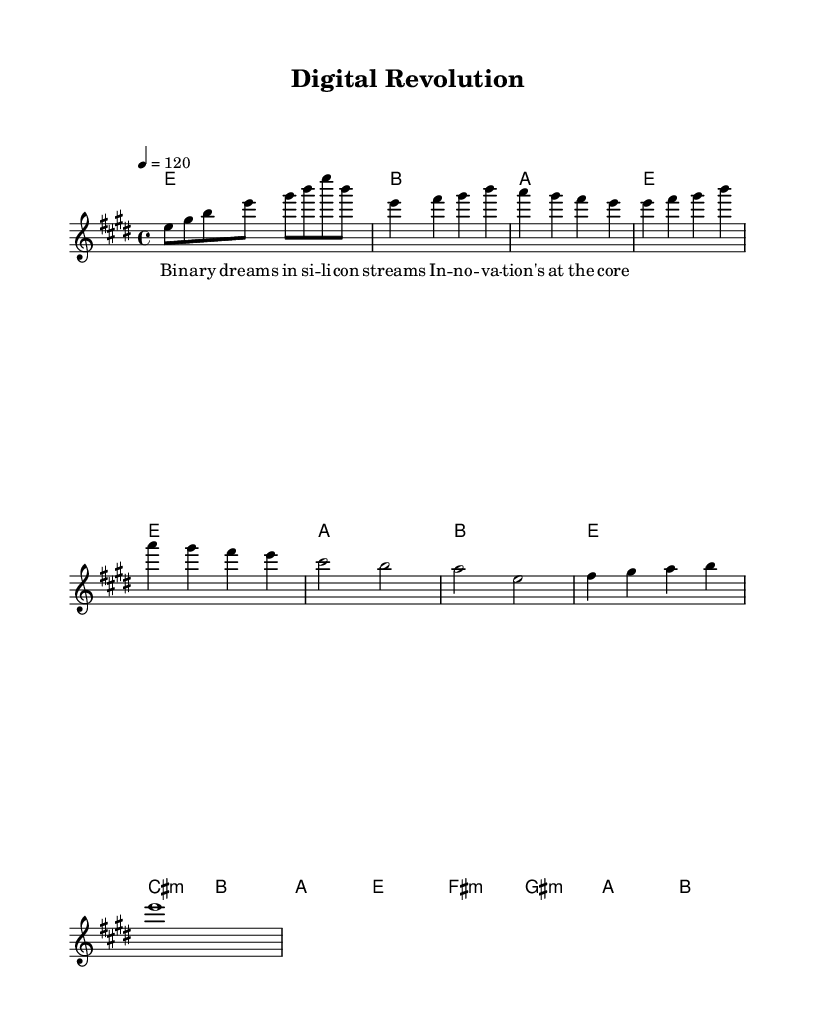What is the key signature of this music? The key signature indicates E major, which contains four sharps (F#, C#, G#, D#). This can be deduced from the key indication at the beginning of the score, denoted by \key e \major.
Answer: E major What is the time signature of this music? The time signature, represented as 4/4, is found at the start of the score. This notation indicates that there are four beats in a measure and the quarter note gets one beat.
Answer: 4/4 What is the tempo marking of this piece? The tempo marking is indicated by the numeral 4 followed by an equals sign and the number 120, which signifies that the tempo is set to 120 beats per minute. This is significant for the performance speed of the piece.
Answer: 120 How many measures are in the intro section? The intro consists of four measures. This can be determined by counting the segments separated by vertical lines in the score, from the first e8 note to the last b note in that section.
Answer: 4 What is the first chord in the harmonies section? The first chord is E major, which is derived from the chord notation shown in the harmonies section at the beginning aligned with the melody. The first notation indicates the E chord, represented as e1.
Answer: E In the chorus, how many different chords are used? There are four different chords used in the chorus section: C# minor, B, A, and E. This can be established by analyzing the chord symbols written above the respective melody notes in the chorus.
Answer: 4 